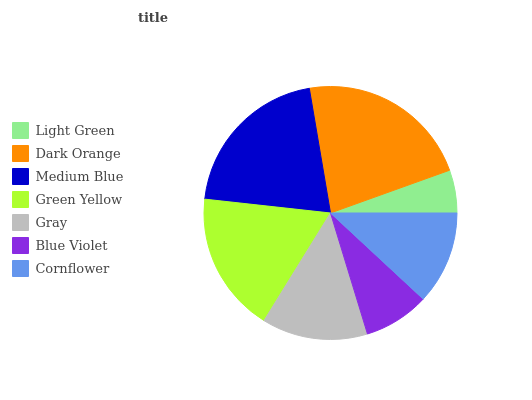Is Light Green the minimum?
Answer yes or no. Yes. Is Dark Orange the maximum?
Answer yes or no. Yes. Is Medium Blue the minimum?
Answer yes or no. No. Is Medium Blue the maximum?
Answer yes or no. No. Is Dark Orange greater than Medium Blue?
Answer yes or no. Yes. Is Medium Blue less than Dark Orange?
Answer yes or no. Yes. Is Medium Blue greater than Dark Orange?
Answer yes or no. No. Is Dark Orange less than Medium Blue?
Answer yes or no. No. Is Gray the high median?
Answer yes or no. Yes. Is Gray the low median?
Answer yes or no. Yes. Is Dark Orange the high median?
Answer yes or no. No. Is Dark Orange the low median?
Answer yes or no. No. 